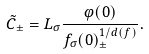Convert formula to latex. <formula><loc_0><loc_0><loc_500><loc_500>\tilde { C } _ { \pm } = L _ { \sigma } \frac { \varphi ( 0 ) } { f _ { \sigma } ( 0 ) ^ { 1 / d ( f ) } _ { \pm } } .</formula> 